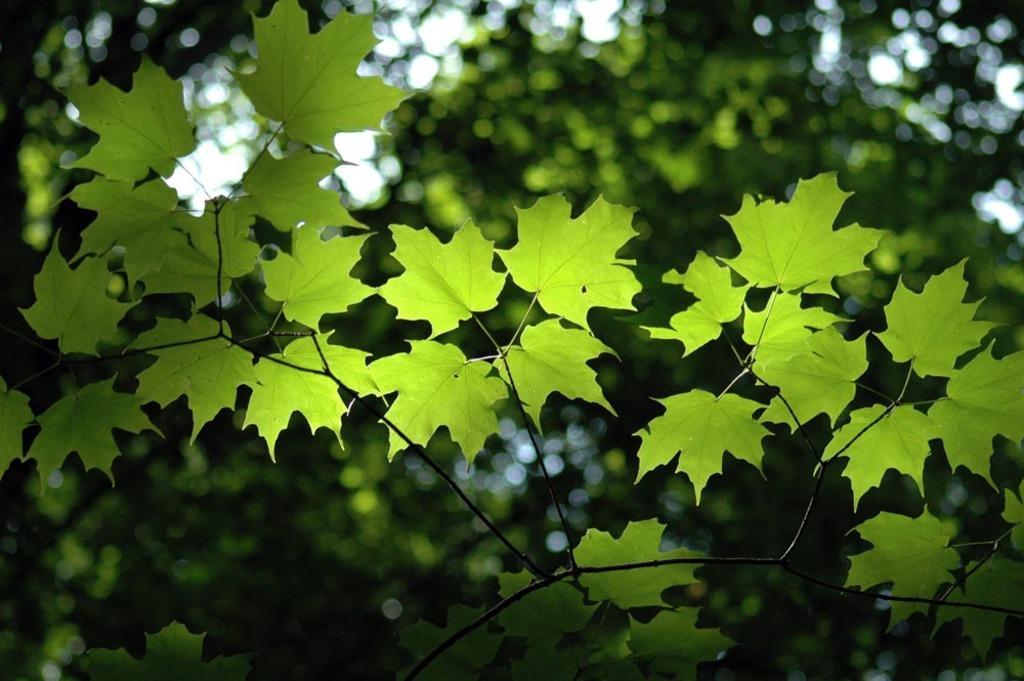Could you give a brief overview of what you see in this image? In this image we can see some leaves, also we can see trees, and the sky, the background is blurred. 